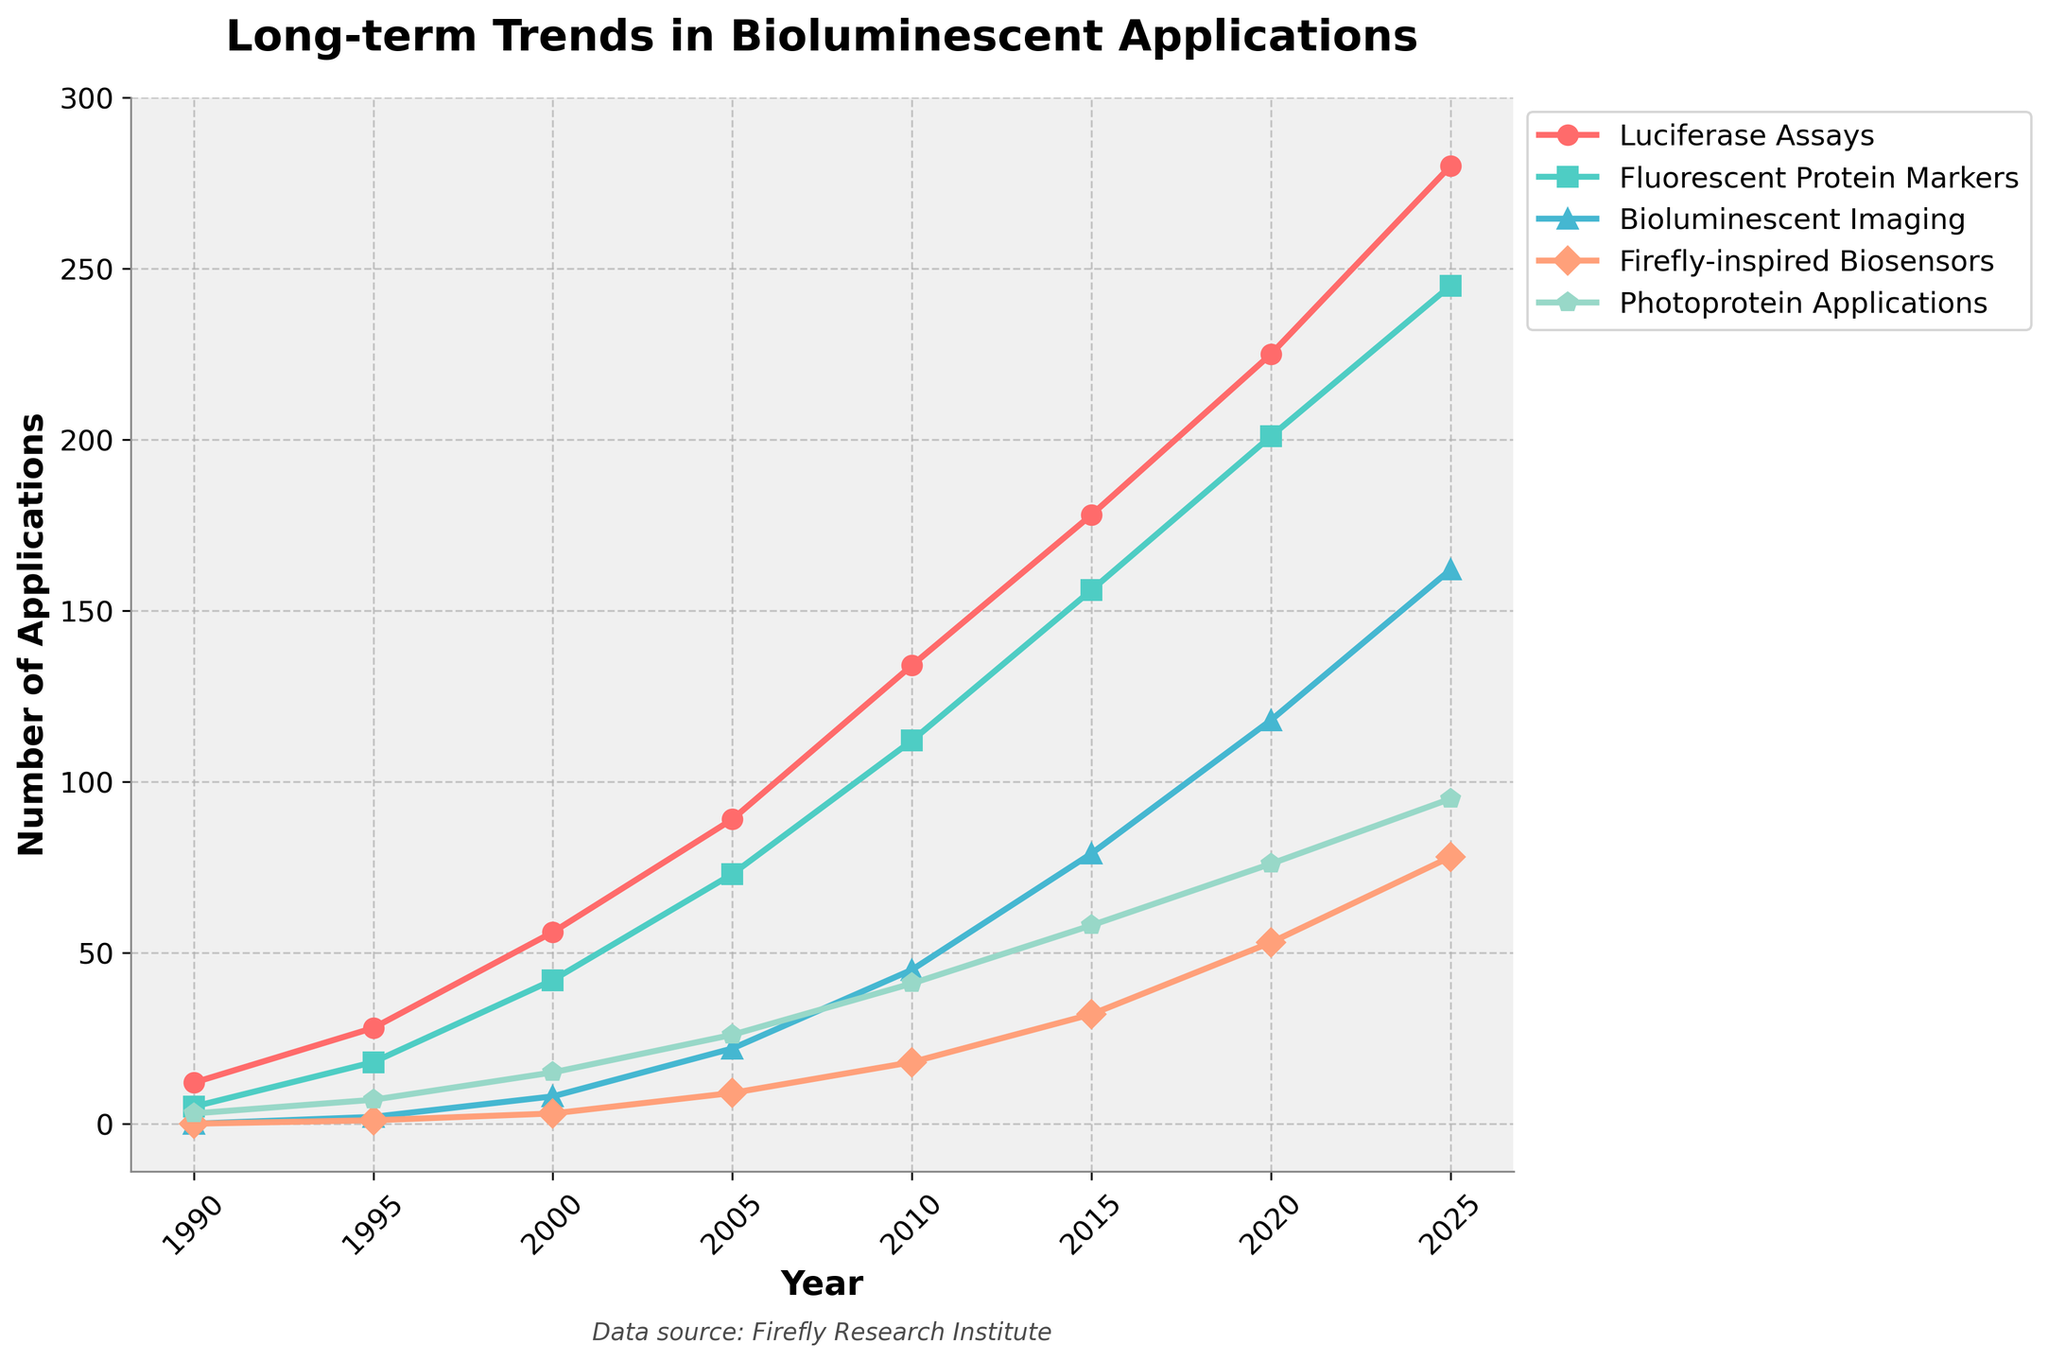What year saw the highest number of applications for Bioluminescent Imaging? The line representing Bioluminescent Imaging shows its peak point at the far-right end of the graph. By examining this point, we can see that it occurs in the year 2025.
Answer: 2025 How many total applications were there for Luciferase Assays and Fluorescent Protein Markers in the year 2000? The number of applications for Luciferase Assays in 2000 is 56, and for Fluorescent Protein Markers, it is 42. Adding these two values gives us 56 + 42.
Answer: 98 Which application showed the greatest increase in the number of applications from 1990 to 2025? To find this, we need to look at the difference in the number of applications between 2025 and 1990 for each category. The differences are:
   - Luciferase Assays: 280 - 12 = 268
   - Fluorescent Protein Markers: 245 - 5 = 240
   - Bioluminescent Imaging: 162 - 0 = 162
   - Firefly-inspired Biosensors: 78 - 0 = 78
   - Photoprotein Applications: 95 - 3 = 92
   The largest increase is 268 for Luciferase Assays.
Answer: Luciferase Assays In which year did the number of applications for Fluorescent Protein Markers first surpass those for Luciferase Assays? By examining the lines for both applications, we see that the number of Fluorescent Protein Markers never surpasses that of Luciferase Assays from 1990 to 2025.
Answer: Never What is the average number of applications for Firefly-inspired Biosensors over the displayed years? The total number of applications for Firefly-inspired Biosensors across all years is 0 + 1 + 3 + 9 + 18 + 32 + 53 + 78 = 194. The number of years is 8. So, the average is 194 / 8.
Answer: 24.25 In 2010, which application had the closest number of applications compared to Photoprotein Applications? In 2010, Photoprotein Applications had 41 applications. Comparing this to the other applications: 
   - Luciferase Assays: 134 
   - Fluorescent Protein Markers: 112
   - Bioluminescent Imaging: 45
   - Firefly-inspired Biosensors: 18
   Bioluminescent Imaging with 45 applications is the closest to 41.
Answer: Bioluminescent Imaging During which year did the Luciferase Assays experience the largest year-over-year increase, and what was the value of that increase? Calculating the year-over-year increases for Luciferase Assays:
   - 1995-1990: 28 - 12 = 16
   - 2000-1995: 56 - 28 = 28
   - 2005-2000: 89 - 56 = 33
   - 2010-2005: 134 - 89 = 45
   - 2015-2010: 178 - 134 = 44
   - 2020-2015: 225 - 178 = 47
   - 2025-2020: 280 - 225 = 55
   The largest increase occurred between 2020 and 2025, with a value of 55.
Answer: 2025, 55 Which application had the fewest total number of applications in 2010? Looking at the 2010 data points:
   - Luciferase Assays: 134
   - Fluorescent Protein Markers: 112
   - Bioluminescent Imaging: 45
   - Firefly-inspired Biosensors: 18
   - Photoprotein Applications: 41 
   The fewest is Firefly-inspired Biosensors with 18 applications.
Answer: Firefly-inspired Biosensors 